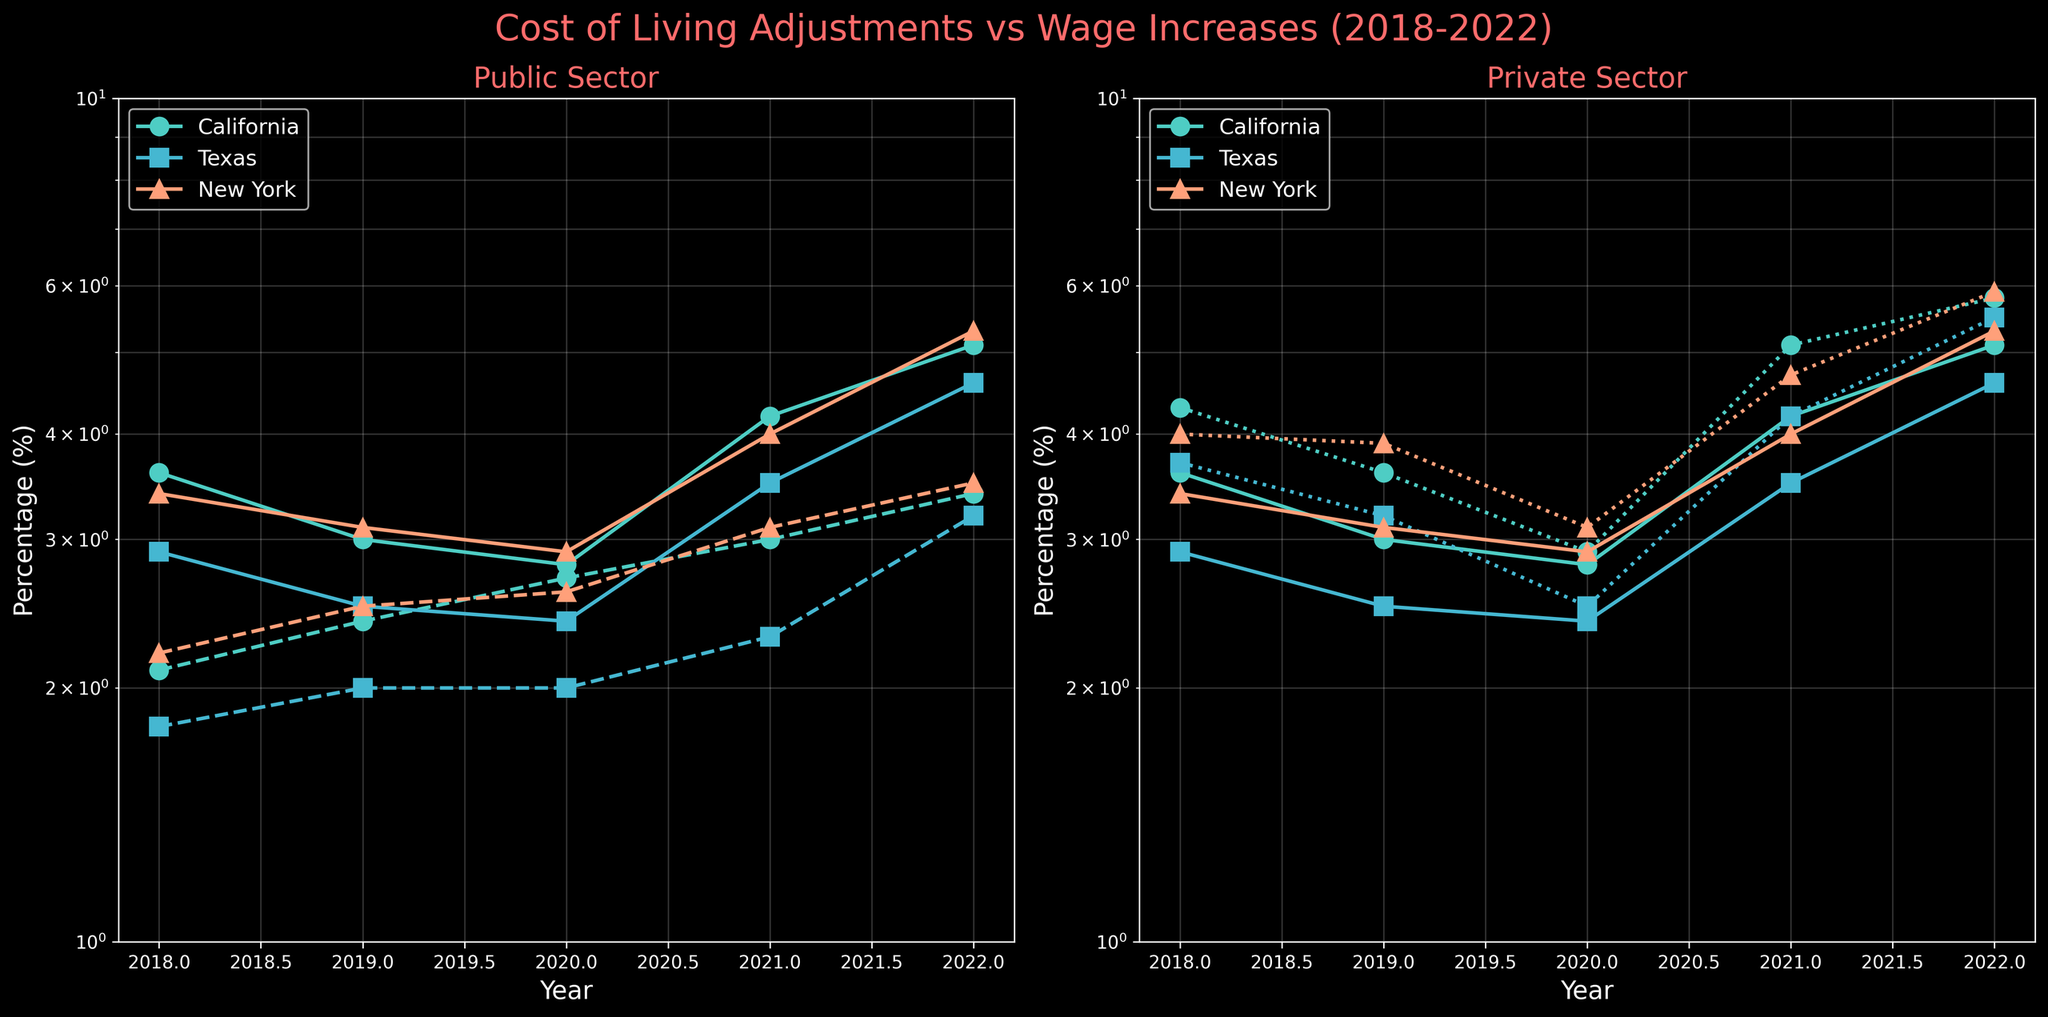What is the time range displayed in the figure? The x-axis in both subplots shows the years from 2018 to 2022.
Answer: 2018-2022 Which state had the highest Cost of Living Adjustment in 2022? By looking at the right end of the graph for each state in both subplots, California had the highest Cost of Living Adjustment in 2022 as indicated by the topmost line on the log scale.
Answer: California What is the overall trend of the Cost of Living Adjustment from 2018 to 2022 in Texas? Following the log-scale line for Texas in both subplots from left to right, the Cost of Living Adjustment shows an increasing trend over these years.
Answer: Increasing How do the Public Sector Wage Increase and Cost of Living Adjustment values for California compare in 2021? In the left subplot, for the year 2021, the orange line (Public Sector Wage Increase) and the corresponding marker for California show a Public Sector Wage Increase of 3.0% and a Cost of Living Adjustment of 4.2%.
Answer: 3.0% for wage increase, 4.2% for adjustment Which sector in New York experienced a steeper growth in wages from 2021 to 2022, the public or the private sector? Comparing the slopes of the respective log-scale lines between 2021 and 2022 for New York in the subplots, the private sector (right subplot, orange line) shows a steeper increase compared to the public sector (left subplot, orange line).
Answer: Private sector What is the average Public Sector Wage Increase for Texas over the five years? Summing the Public Sector Wage Increase values for Texas (1.8 + 2.0 + 2.0 + 2.3 + 3.2) and then dividing by 5, the average is (1.8 + 2.0 + 2.0 + 2.3 + 3.2) / 5 = 2.26%.
Answer: 2.26% Is there any year where the Public Sector Wage Increase surpasses the Cost of Living Adjustment for California? Checking the respective lines for California in all years in the left subplot, there is no instance where the Public Sector Wage Increase (dashed line) is higher than the Cost of Living Adjustment (solid line). The former line is always below the latter.
Answer: No Which state had the largest gap between Cost of Living Adjustment and Private Sector Wage Increase in 2020? Referring to the right subplot for the year 2020, the difference is largest for California (difference between topmost and its corresponding dotted line).
Answer: California What is the trend difference between Public and Private Sector Wage Increases across the states from 2018 to 2022? Comparing the lines for Public and Private sectors in the two subplots, Private Sector Wage Increases (right subplot) show more pronounced increases compared to the more modest increases in the Public Sector (left subplot).
Answer: Private shows pronounced increases Between 2018 and 2022, which state had a Public Sector Wage Increase that consistently stayed below its Cost of Living Adjustment throughout all years? Observing the left subplot, for each year, the lines corresponding to all three states have the dashed (Public Sector Wage Increase) always below the solid (Cost of Living Adjustment), indicating all states have this condition.
Answer: All states 